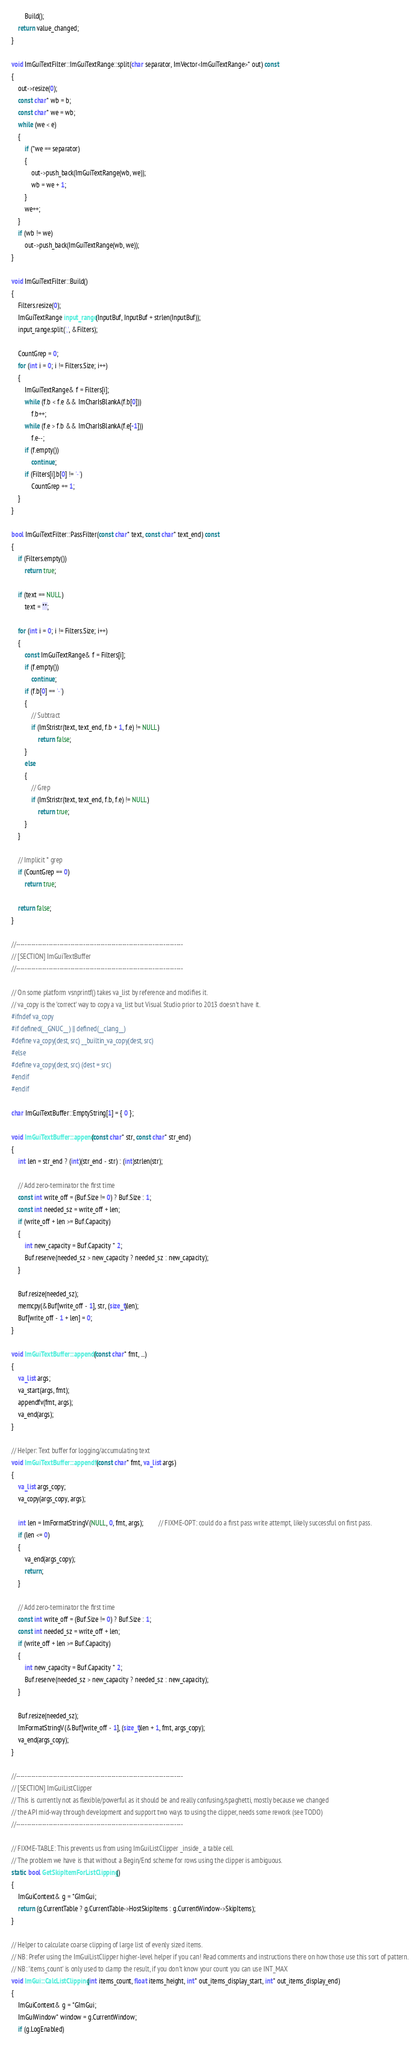<code> <loc_0><loc_0><loc_500><loc_500><_C++_>        Build();
    return value_changed;
}

void ImGuiTextFilter::ImGuiTextRange::split(char separator, ImVector<ImGuiTextRange>* out) const
{
    out->resize(0);
    const char* wb = b;
    const char* we = wb;
    while (we < e)
    {
        if (*we == separator)
        {
            out->push_back(ImGuiTextRange(wb, we));
            wb = we + 1;
        }
        we++;
    }
    if (wb != we)
        out->push_back(ImGuiTextRange(wb, we));
}

void ImGuiTextFilter::Build()
{
    Filters.resize(0);
    ImGuiTextRange input_range(InputBuf, InputBuf + strlen(InputBuf));
    input_range.split(',', &Filters);

    CountGrep = 0;
    for (int i = 0; i != Filters.Size; i++)
    {
        ImGuiTextRange& f = Filters[i];
        while (f.b < f.e && ImCharIsBlankA(f.b[0]))
            f.b++;
        while (f.e > f.b && ImCharIsBlankA(f.e[-1]))
            f.e--;
        if (f.empty())
            continue;
        if (Filters[i].b[0] != '-')
            CountGrep += 1;
    }
}

bool ImGuiTextFilter::PassFilter(const char* text, const char* text_end) const
{
    if (Filters.empty())
        return true;

    if (text == NULL)
        text = "";

    for (int i = 0; i != Filters.Size; i++)
    {
        const ImGuiTextRange& f = Filters[i];
        if (f.empty())
            continue;
        if (f.b[0] == '-')
        {
            // Subtract
            if (ImStristr(text, text_end, f.b + 1, f.e) != NULL)
                return false;
        }
        else
        {
            // Grep
            if (ImStristr(text, text_end, f.b, f.e) != NULL)
                return true;
        }
    }

    // Implicit * grep
    if (CountGrep == 0)
        return true;

    return false;
}

//-----------------------------------------------------------------------------
// [SECTION] ImGuiTextBuffer
//-----------------------------------------------------------------------------

// On some platform vsnprintf() takes va_list by reference and modifies it.
// va_copy is the 'correct' way to copy a va_list but Visual Studio prior to 2013 doesn't have it.
#ifndef va_copy
#if defined(__GNUC__) || defined(__clang__)
#define va_copy(dest, src) __builtin_va_copy(dest, src)
#else
#define va_copy(dest, src) (dest = src)
#endif
#endif

char ImGuiTextBuffer::EmptyString[1] = { 0 };

void ImGuiTextBuffer::append(const char* str, const char* str_end)
{
    int len = str_end ? (int)(str_end - str) : (int)strlen(str);

    // Add zero-terminator the first time
    const int write_off = (Buf.Size != 0) ? Buf.Size : 1;
    const int needed_sz = write_off + len;
    if (write_off + len >= Buf.Capacity)
    {
        int new_capacity = Buf.Capacity * 2;
        Buf.reserve(needed_sz > new_capacity ? needed_sz : new_capacity);
    }

    Buf.resize(needed_sz);
    memcpy(&Buf[write_off - 1], str, (size_t)len);
    Buf[write_off - 1 + len] = 0;
}

void ImGuiTextBuffer::appendf(const char* fmt, ...)
{
    va_list args;
    va_start(args, fmt);
    appendfv(fmt, args);
    va_end(args);
}

// Helper: Text buffer for logging/accumulating text
void ImGuiTextBuffer::appendfv(const char* fmt, va_list args)
{
    va_list args_copy;
    va_copy(args_copy, args);

    int len = ImFormatStringV(NULL, 0, fmt, args);         // FIXME-OPT: could do a first pass write attempt, likely successful on first pass.
    if (len <= 0)
    {
        va_end(args_copy);
        return;
    }

    // Add zero-terminator the first time
    const int write_off = (Buf.Size != 0) ? Buf.Size : 1;
    const int needed_sz = write_off + len;
    if (write_off + len >= Buf.Capacity)
    {
        int new_capacity = Buf.Capacity * 2;
        Buf.reserve(needed_sz > new_capacity ? needed_sz : new_capacity);
    }

    Buf.resize(needed_sz);
    ImFormatStringV(&Buf[write_off - 1], (size_t)len + 1, fmt, args_copy);
    va_end(args_copy);
}

//-----------------------------------------------------------------------------
// [SECTION] ImGuiListClipper
// This is currently not as flexible/powerful as it should be and really confusing/spaghetti, mostly because we changed
// the API mid-way through development and support two ways to using the clipper, needs some rework (see TODO)
//-----------------------------------------------------------------------------

// FIXME-TABLE: This prevents us from using ImGuiListClipper _inside_ a table cell.
// The problem we have is that without a Begin/End scheme for rows using the clipper is ambiguous.
static bool GetSkipItemForListClipping()
{
    ImGuiContext& g = *GImGui;
    return (g.CurrentTable ? g.CurrentTable->HostSkipItems : g.CurrentWindow->SkipItems);
}

// Helper to calculate coarse clipping of large list of evenly sized items.
// NB: Prefer using the ImGuiListClipper higher-level helper if you can! Read comments and instructions there on how those use this sort of pattern.
// NB: 'items_count' is only used to clamp the result, if you don't know your count you can use INT_MAX
void ImGui::CalcListClipping(int items_count, float items_height, int* out_items_display_start, int* out_items_display_end)
{
    ImGuiContext& g = *GImGui;
    ImGuiWindow* window = g.CurrentWindow;
    if (g.LogEnabled)</code> 